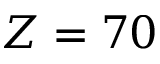<formula> <loc_0><loc_0><loc_500><loc_500>Z = 7 0</formula> 